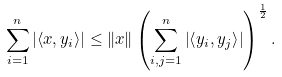Convert formula to latex. <formula><loc_0><loc_0><loc_500><loc_500>\sum _ { i = 1 } ^ { n } \left | \left \langle x , y _ { i } \right \rangle \right | \leq \left \| x \right \| \left ( \sum _ { i , j = 1 } ^ { n } \left | \left \langle y _ { i } , y _ { j } \right \rangle \right | \right ) ^ { \frac { 1 } { 2 } } .</formula> 